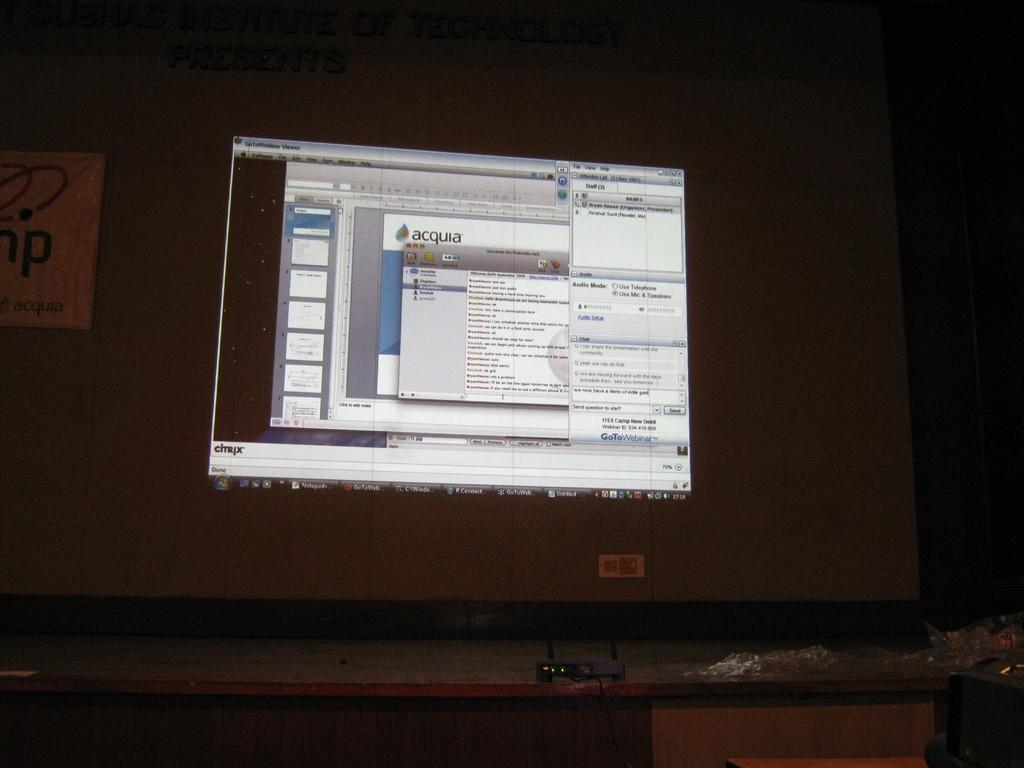Provide a one-sentence caption for the provided image. Computer monitor which shows the word Acquia on the screen. 